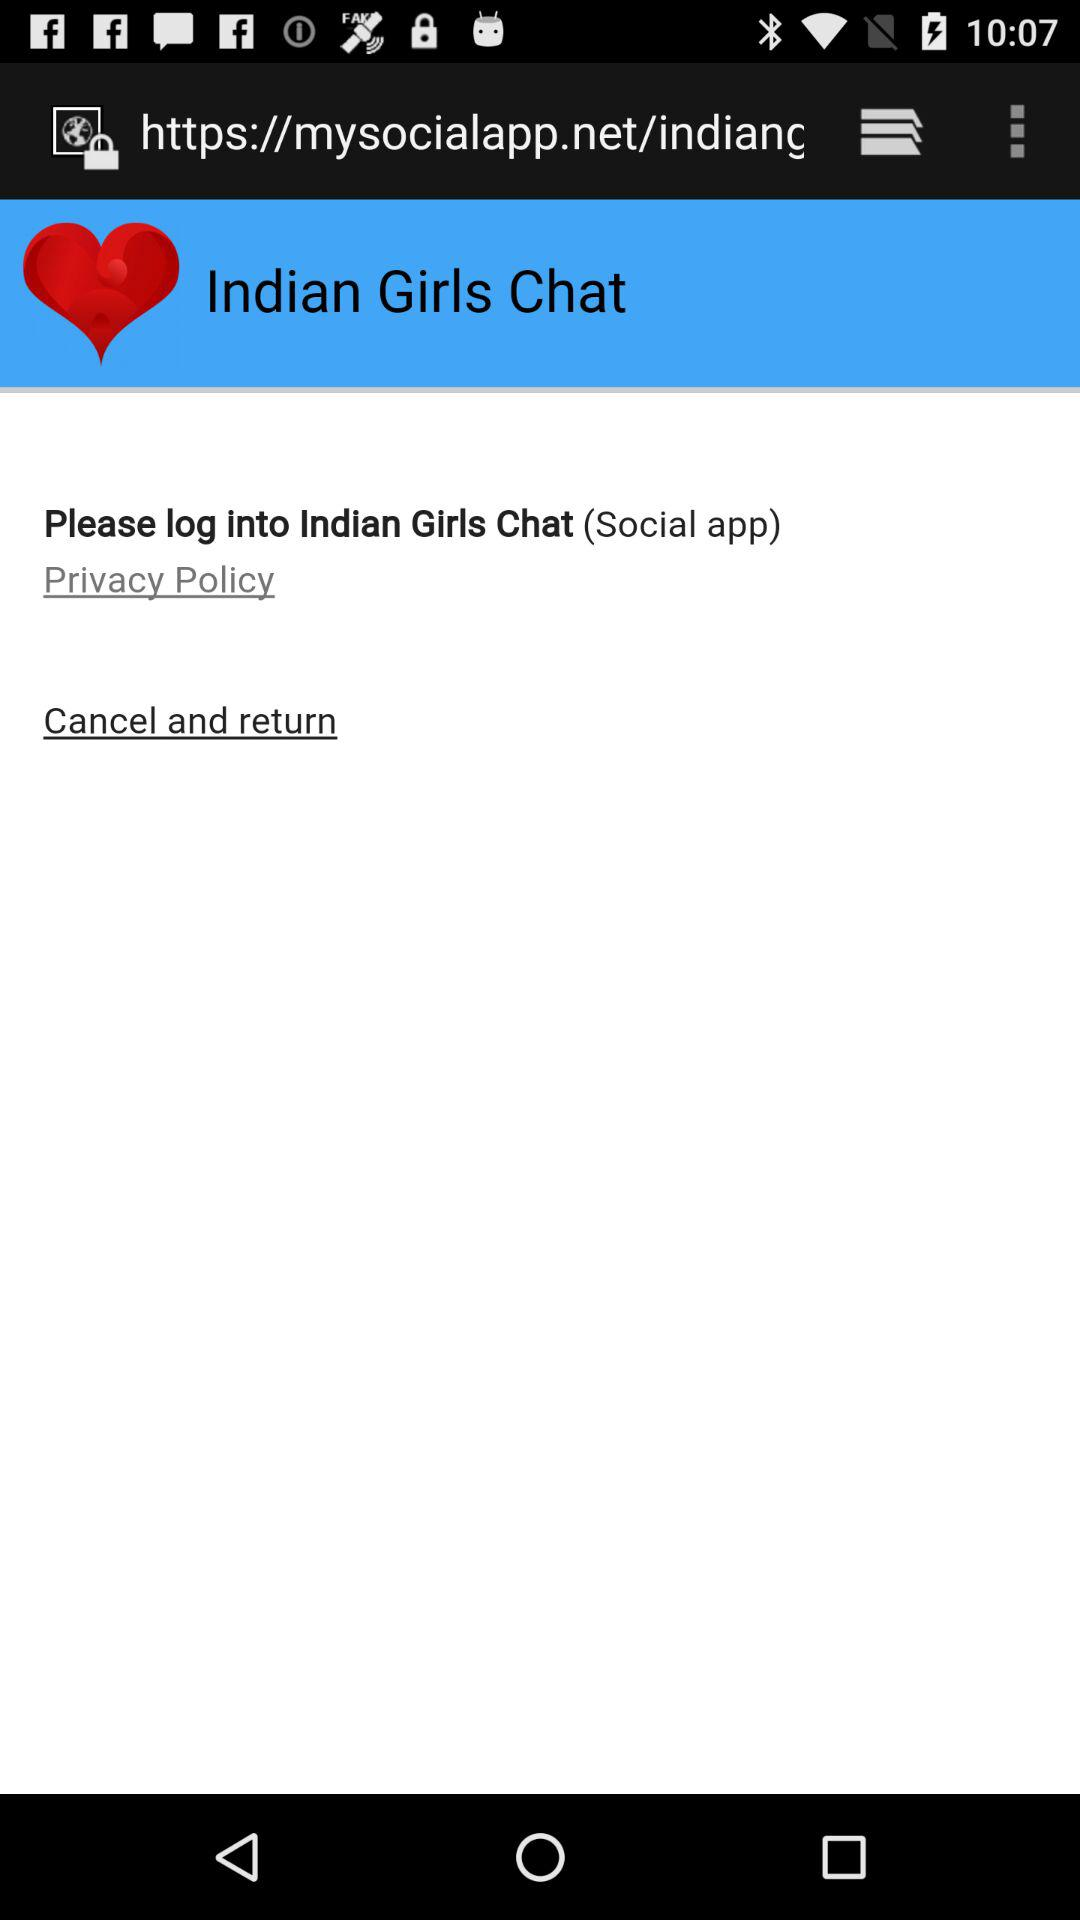What is the name of the application? The name of the application is "Indian Girls Chat". 